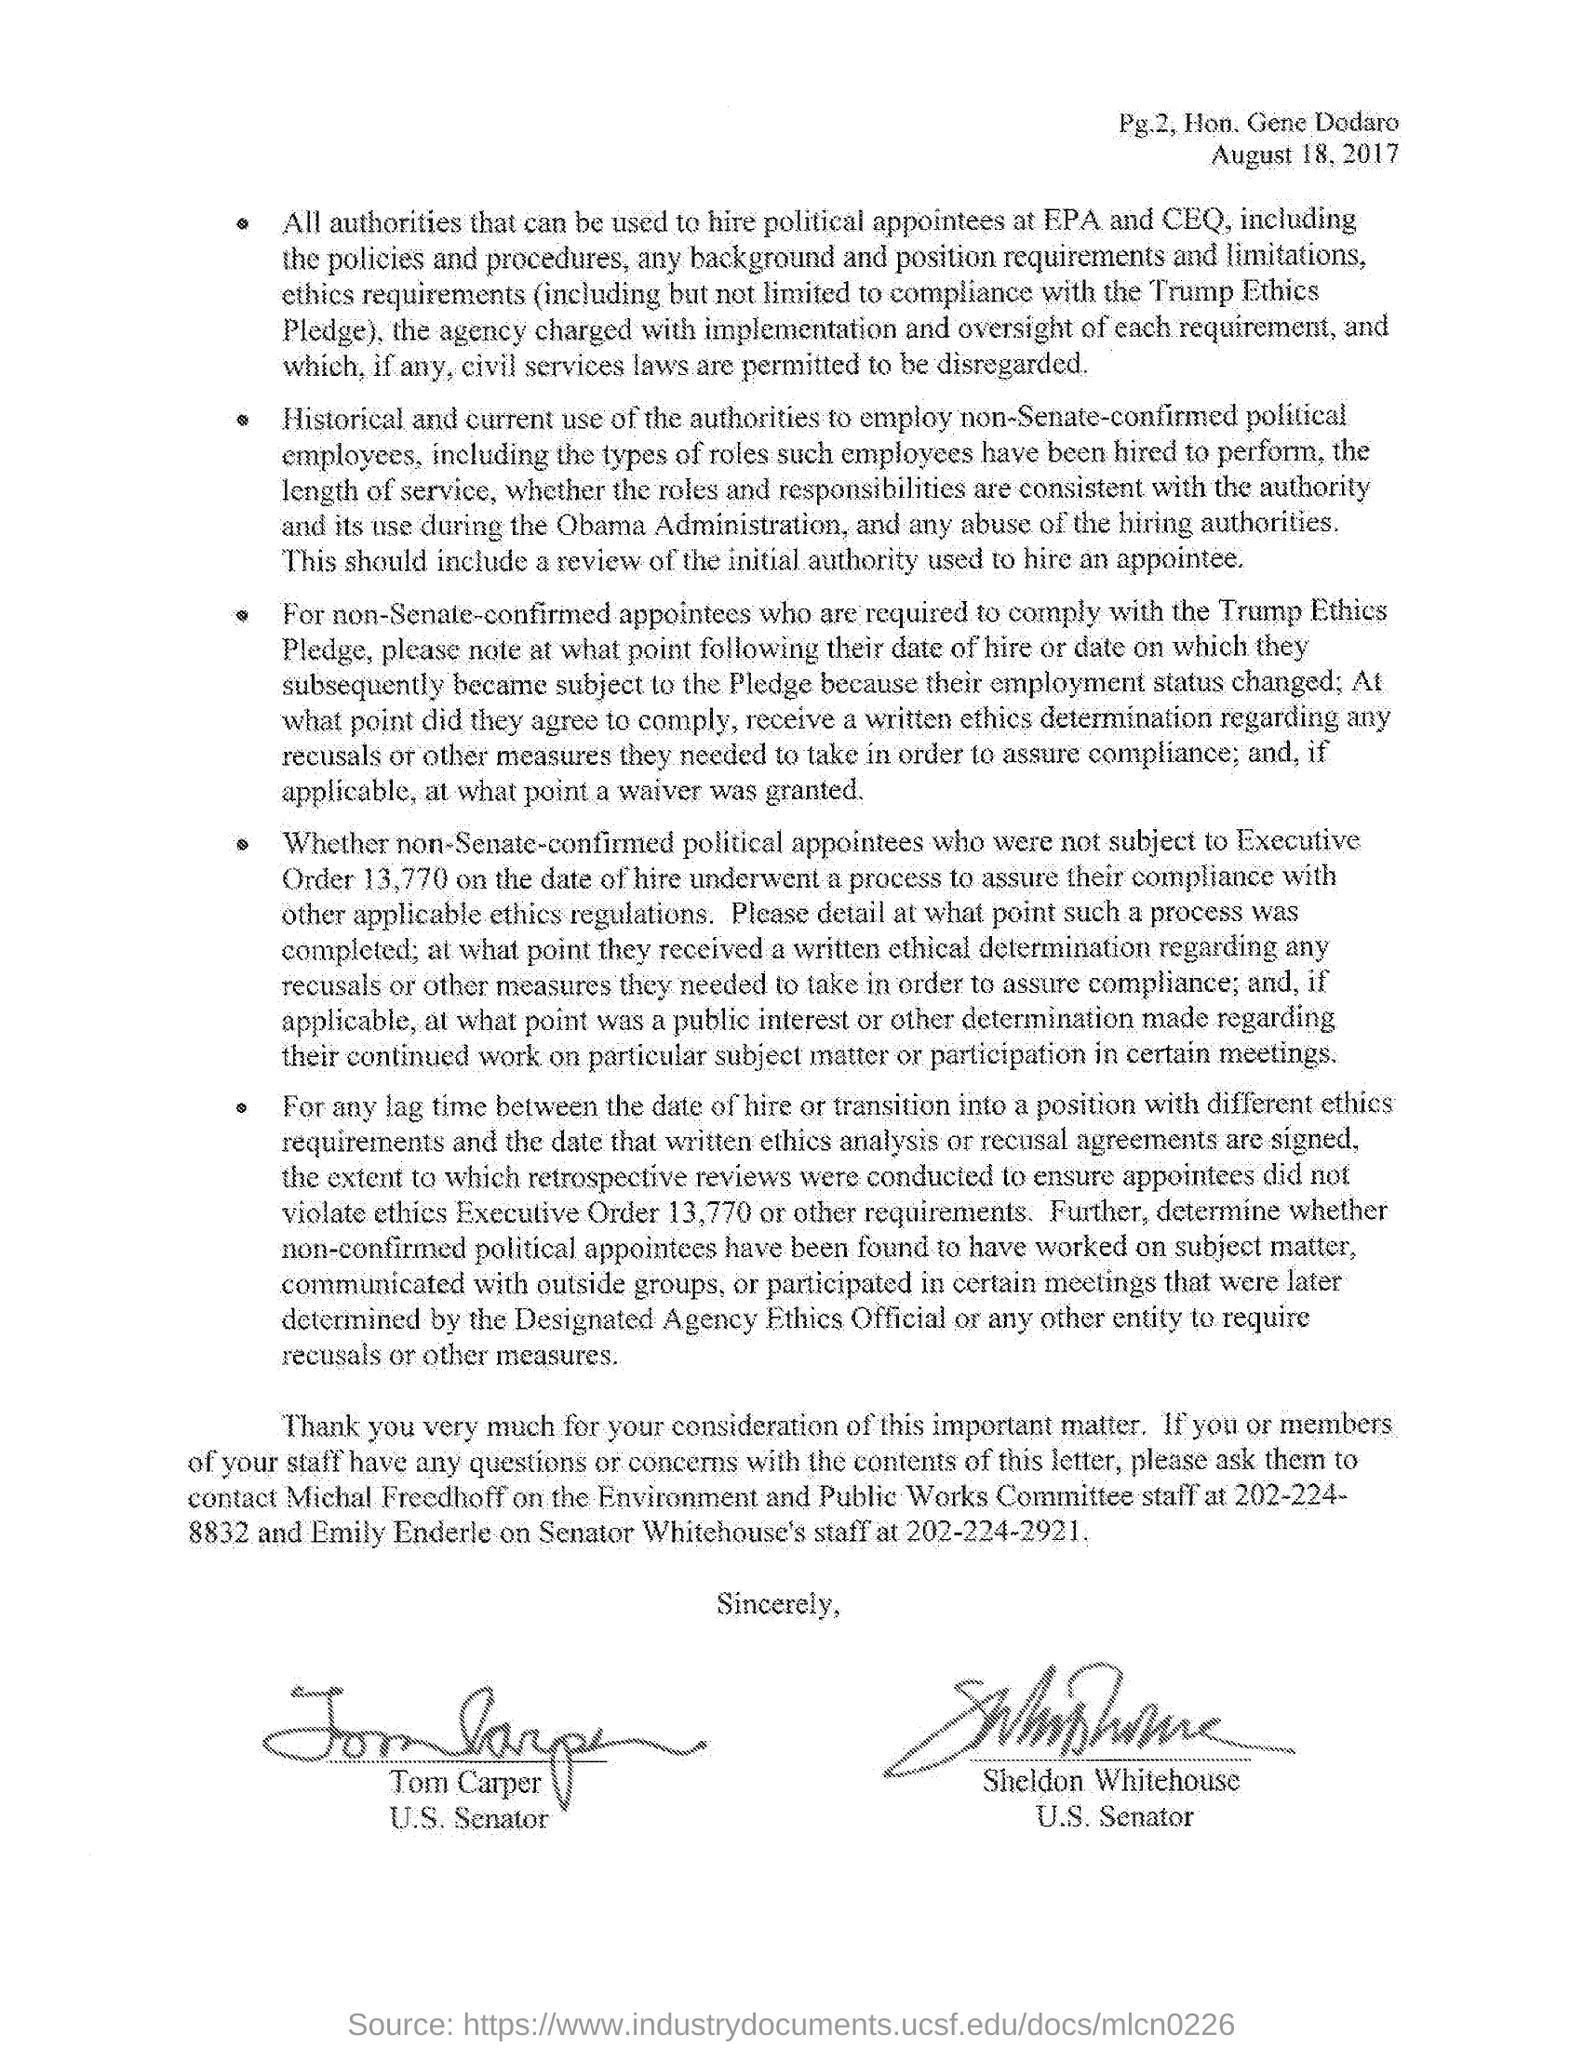What is the Date of the document ?
Keep it short and to the point. August 18, 2017. What is the name of  Environment and Public Works Committee staff?
Offer a very short reply. Michal Freedhoff. Who is Emily Enderle?
Provide a succinct answer. Senator Whitehouse's staff. What is the contact number of Environment and Public Works Committe staff?
Make the answer very short. 202-224-8832. Who is Tom Carper?
Keep it short and to the point. U.S. Senator. 